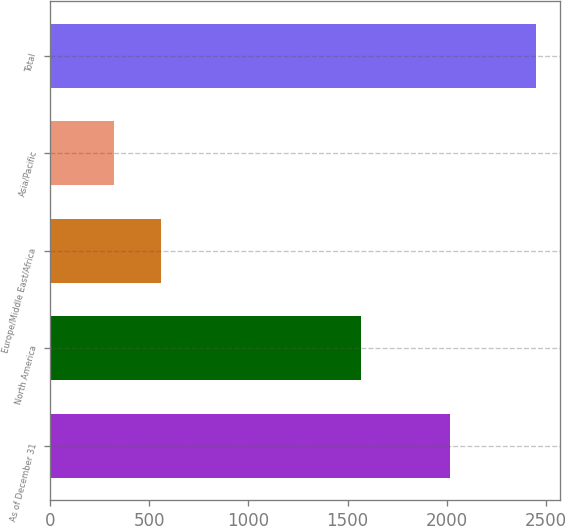Convert chart. <chart><loc_0><loc_0><loc_500><loc_500><bar_chart><fcel>As of December 31<fcel>North America<fcel>Europe/Middle East/Africa<fcel>Asia/Pacific<fcel>Total<nl><fcel>2014<fcel>1568<fcel>559<fcel>321<fcel>2448<nl></chart> 